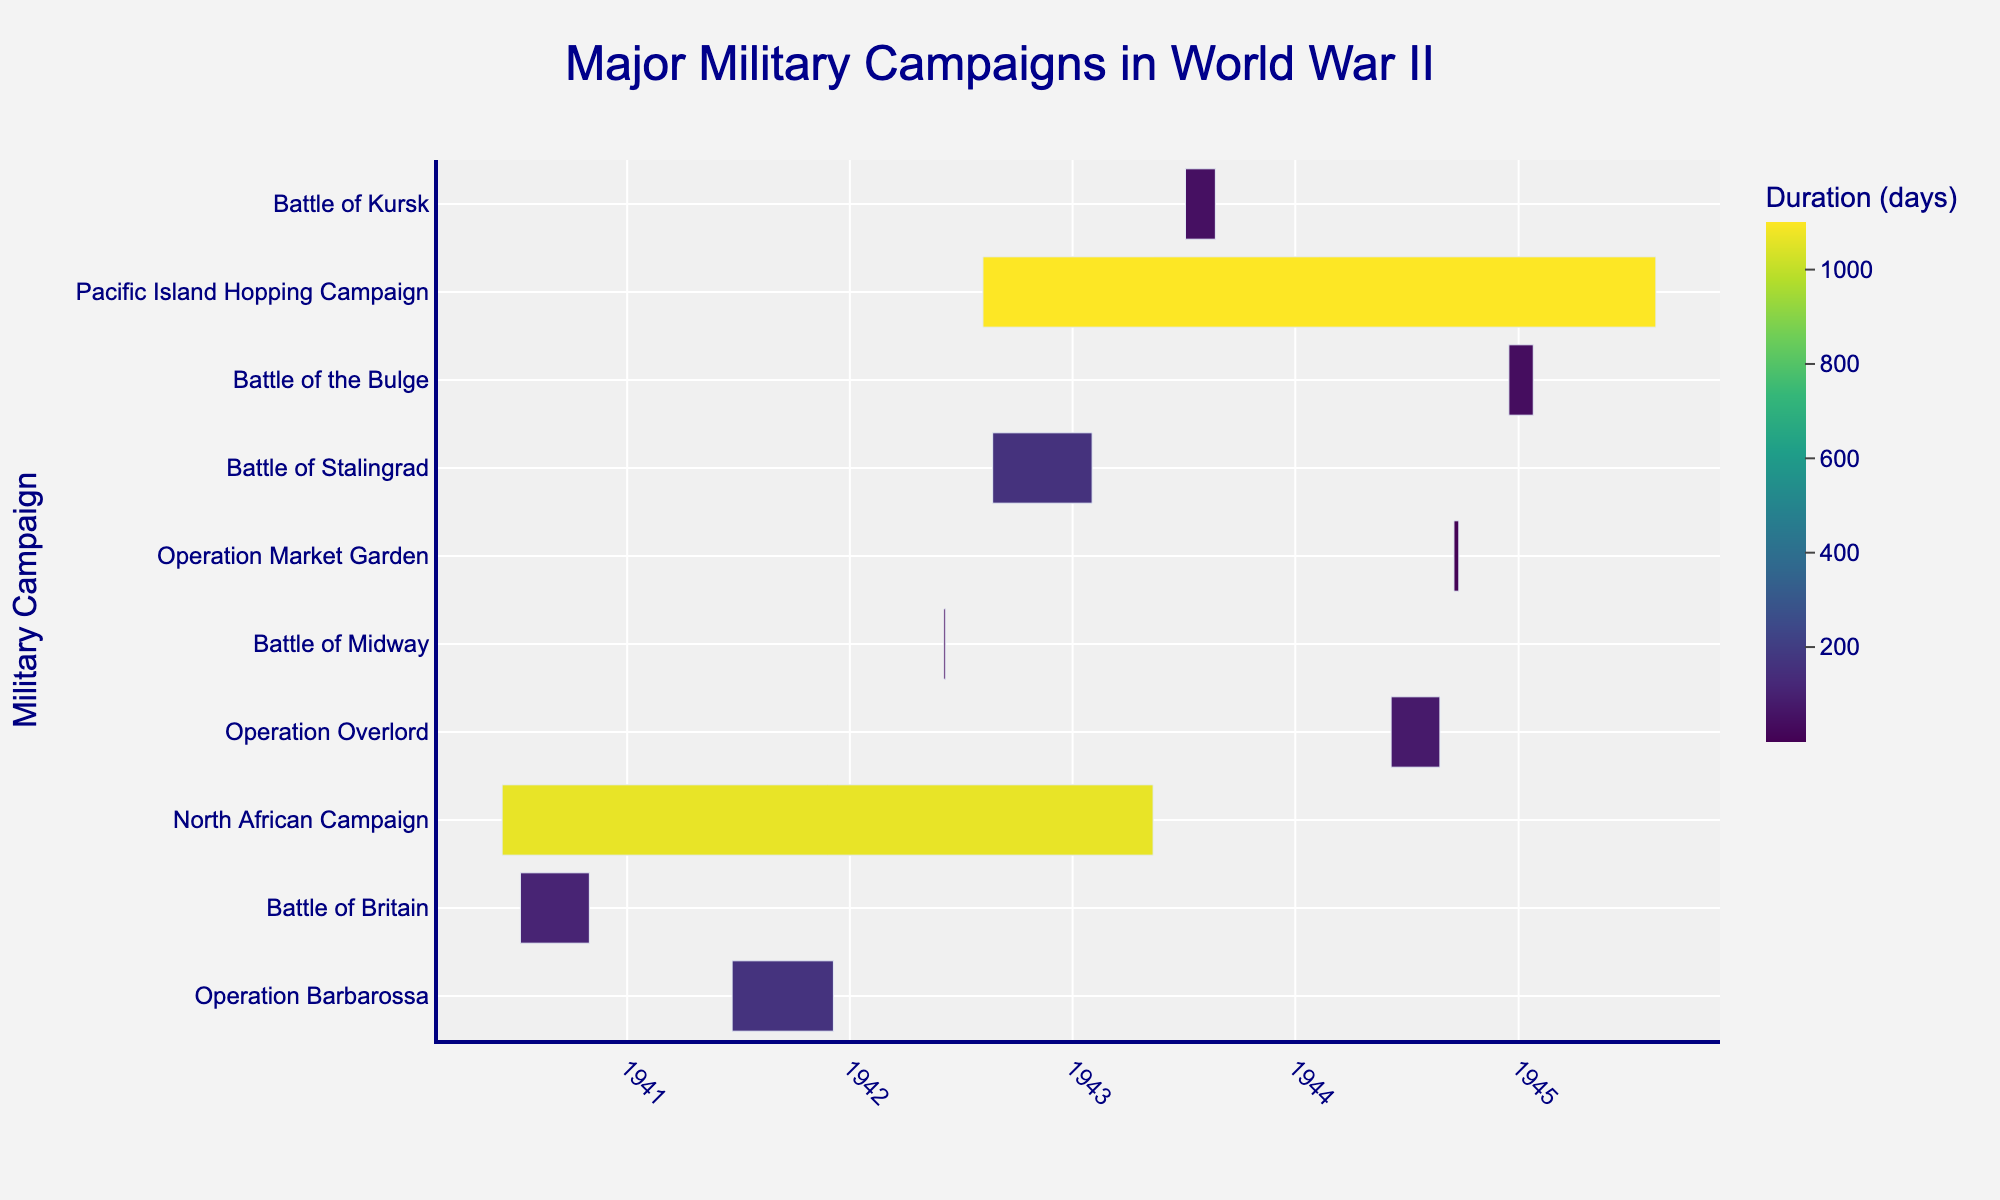What is the title of the chart? To find the title, you need to look at the top of the chart where it is usually prominently displayed.
Answer: Major Military Campaigns in World War II Which campaign lasted the longest? Look at the duration bars on the Gantt chart and identify the longest one. This will be the campaign that lasted the longest.
Answer: Pacific Island Hopping Campaign Which two campaigns started in 1944? Scan the start dates along the timeline axis to find the ones that fall in 1944, then check the corresponding campaigns.
Answer: Operation Overlord, Operation Market Garden How long did the Battle of Stalingrad last? Locate the Battle of Stalingrad on the y-axis and check the duration of its bar. Convert this into the number of days as displayed in the hover information.
Answer: 163 days Which campaign ended in August 1943? Find the campaigns that have their end dates marked in August 1943, using the timeline at the top to identify the month and year.
Answer: Battle of Kursk What is the duration difference between Operation Overlord and the Battle of Midway? First, find the durations of both campaigns from the chart. Subtract the smaller duration from the larger one to find the difference.
Answer: 80 days Which campaign started first, Battle of Britain or North African Campaign? Look at the timeline start dates of both campaigns. Compare the dates to determine which one started first.
Answer: North African Campaign How many campaigns occurred in 1943? Check the start and end dates of each campaign to see how many fall within the year 1943.
Answer: Four Which campaign has the shortest duration? Look for the campaign with the shortest bar along the duration axis.
Answer: Battle of Midway What is the total duration of campaigns that overlapped with the North African Campaign? Identify the campaigns that have overlapping dates with the North African Campaign and sum up their durations.
Answer: 834 days 